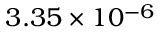Convert formula to latex. <formula><loc_0><loc_0><loc_500><loc_500>3 . 3 5 \times 1 0 ^ { - 6 }</formula> 